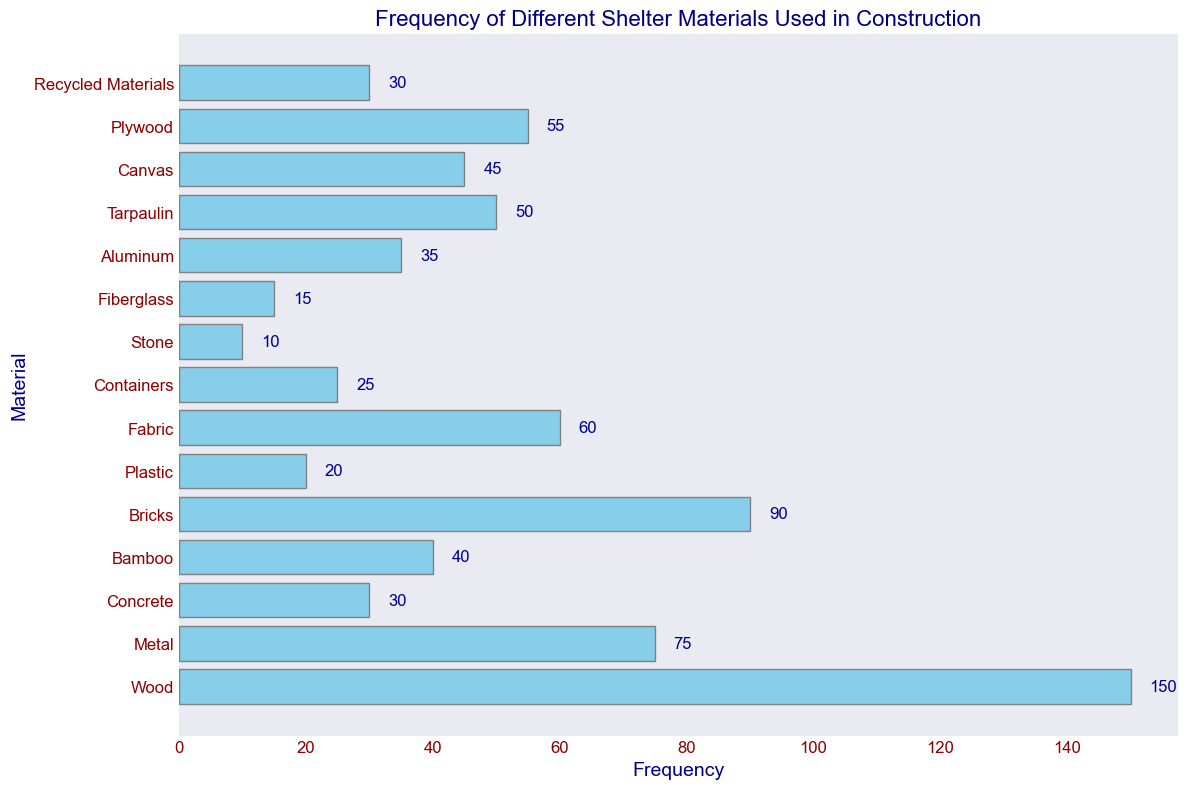Which material is used the most frequently? The bar representing Wood is the longest, indicating it is the most frequently used material.
Answer: Wood Which material has the least frequency of use? The bar representing Stone is the shortest, indicating it has the least frequency of use.
Answer: Stone How many materials have a frequency above 50? The materials with frequencies above 50 are Wood, Metal, Bricks, Fabric, Plywood, and Tarpaulin. Count these items to get the total.
Answer: 6 What is the total frequency for Wood, Metal, and Concrete combined? Sum the frequencies of Wood (150), Metal (75), and Concrete (30): 150 + 75 + 30 = 255
Answer: 255 Which materials have a lower frequency than Plastic? The material with a lower frequency than Plastic (20) are Stone (10) and Fiberglass (15).
Answer: Stone, Fiberglass What is the average frequency of Bamboo and Fiberglass? Sum the frequencies of Bamboo (40) and Fiberglass (15): 40 + 15 = 55. Divide by 2 to find the average: 55/2 = 27.5
Answer: 27.5 What is the frequency difference between the most and the least used materials? Subtract the frequency of Stone (10) from the frequency of Wood (150): 150 - 10 = 140
Answer: 140 How many materials have a frequency between 30 and 60? The materials with frequencies between 30 and 60 are Bamboo (40), Fabric (60), Aluminum (35), Canvas (45), and Plywood (55). Count these items to get the total.
Answer: 5 What is the total frequency of materials used less frequently than Canvas? Sum the frequencies of materials with a lower frequency than Canvas (45): Concrete (30), Plastic (20), Containers (25), Stone (10), Fiberglass (15), and Aluminum (35). Sum: 30 + 20 + 25 + 10 + 15 + 35 = 135
Answer: 135 How does the frequency of Bricks compare to that of Metal? The frequency of Bricks (90) is greater than that of Metal (75).
Answer: Bricks > Metal 